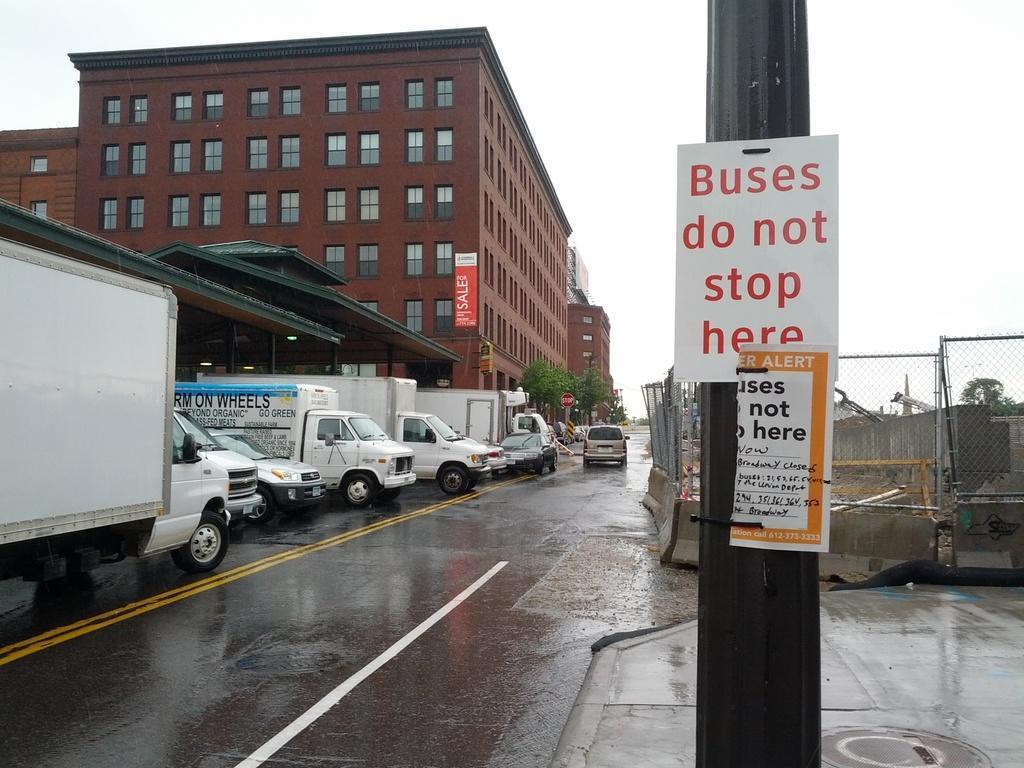In one or two sentences, can you explain what this image depicts? In this image, we can see a few vehicles. We can also see the ground. There are a few buildings. We can also see the fence. We can see a pole with some posters on it. We can also see the sky. There are a few trees. 